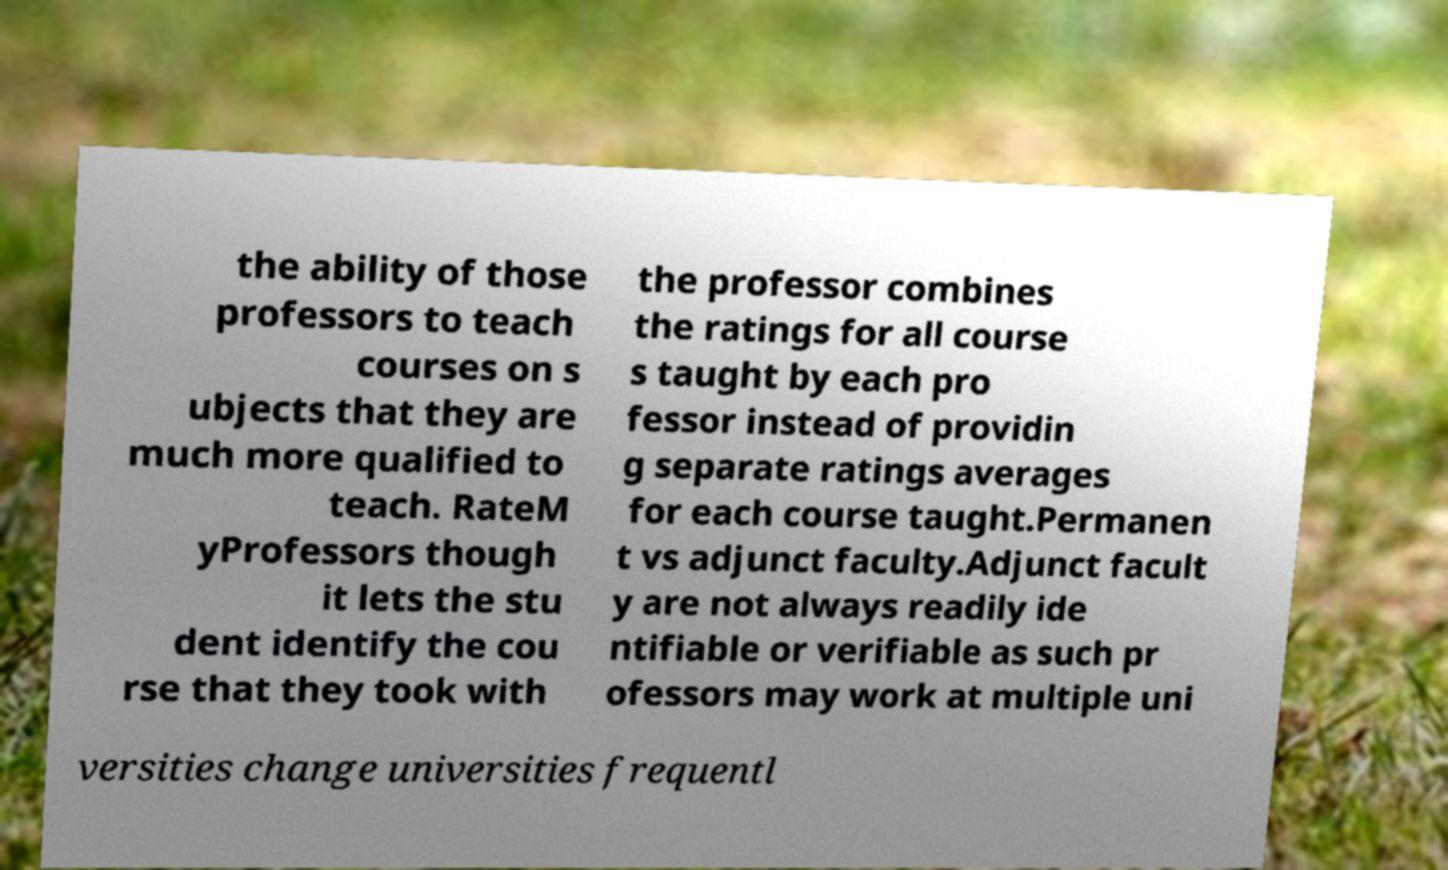I need the written content from this picture converted into text. Can you do that? the ability of those professors to teach courses on s ubjects that they are much more qualified to teach. RateM yProfessors though it lets the stu dent identify the cou rse that they took with the professor combines the ratings for all course s taught by each pro fessor instead of providin g separate ratings averages for each course taught.Permanen t vs adjunct faculty.Adjunct facult y are not always readily ide ntifiable or verifiable as such pr ofessors may work at multiple uni versities change universities frequentl 